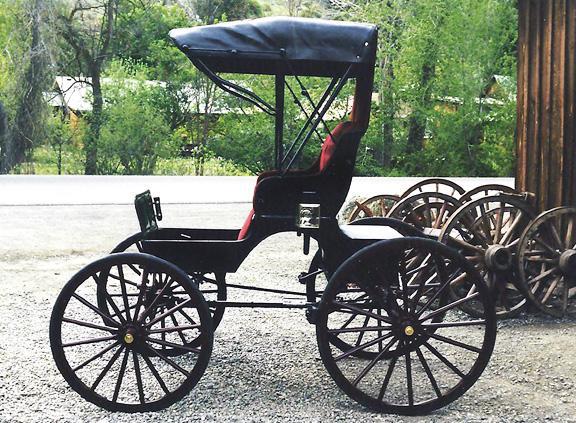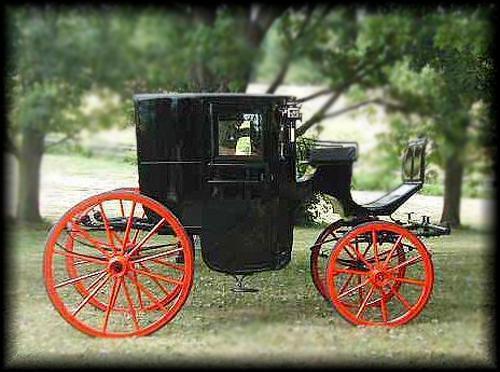The first image is the image on the left, the second image is the image on the right. Analyze the images presented: Is the assertion "In one of the images there is  a carriage with two horses hitched to it." valid? Answer yes or no. No. 